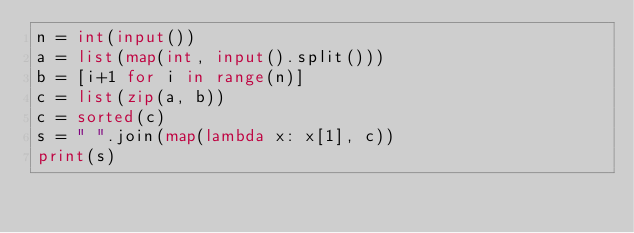Convert code to text. <code><loc_0><loc_0><loc_500><loc_500><_Python_>n = int(input())
a = list(map(int, input().split()))
b = [i+1 for i in range(n)]
c = list(zip(a, b))
c = sorted(c)
s = " ".join(map(lambda x: x[1], c))
print(s)
  </code> 